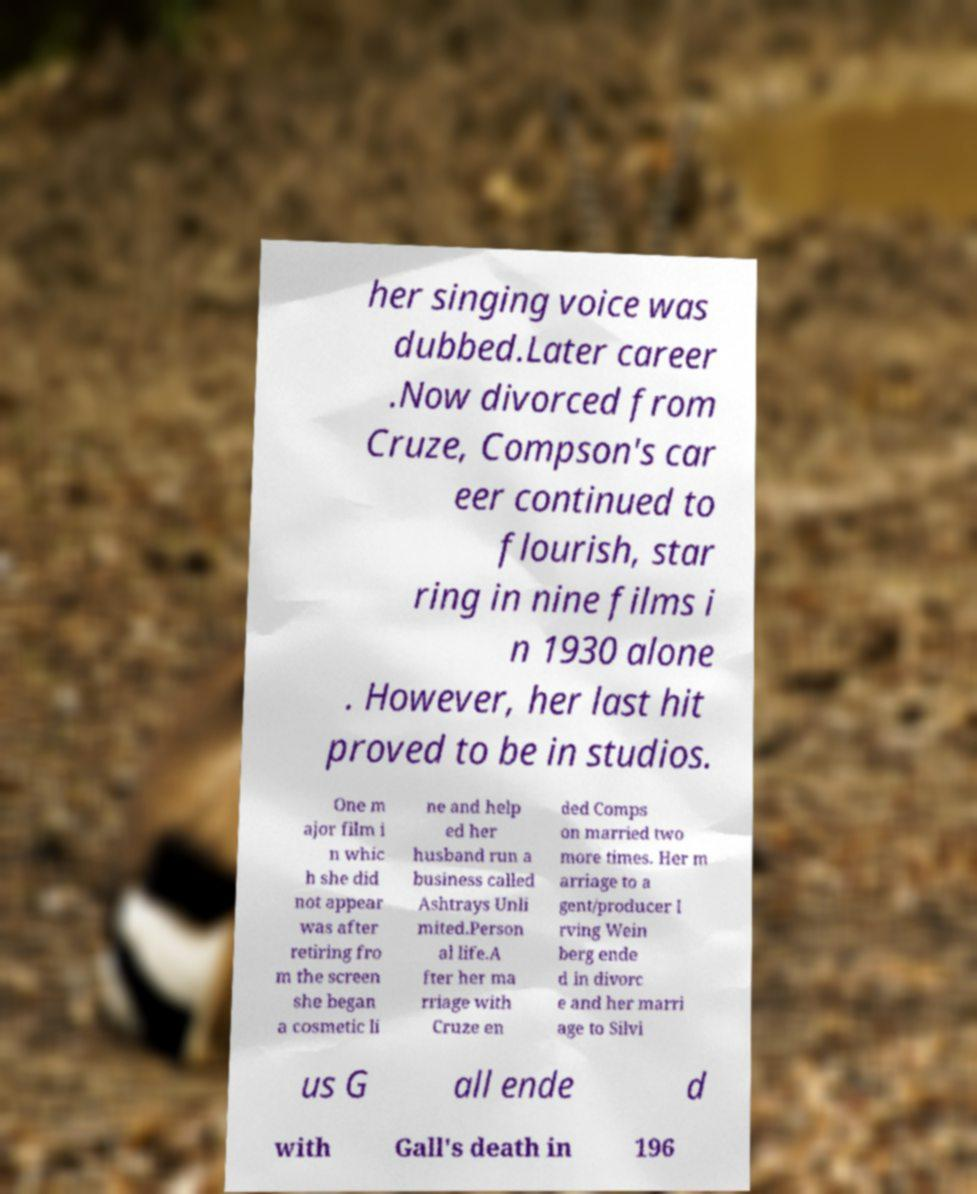I need the written content from this picture converted into text. Can you do that? her singing voice was dubbed.Later career .Now divorced from Cruze, Compson's car eer continued to flourish, star ring in nine films i n 1930 alone . However, her last hit proved to be in studios. One m ajor film i n whic h she did not appear was after retiring fro m the screen she began a cosmetic li ne and help ed her husband run a business called Ashtrays Unli mited.Person al life.A fter her ma rriage with Cruze en ded Comps on married two more times. Her m arriage to a gent/producer I rving Wein berg ende d in divorc e and her marri age to Silvi us G all ende d with Gall's death in 196 